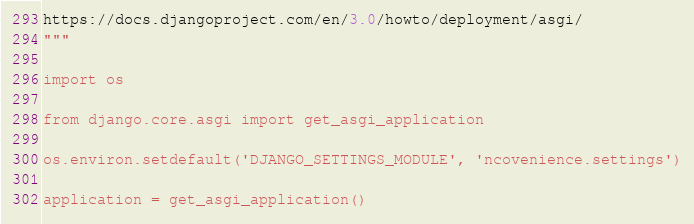<code> <loc_0><loc_0><loc_500><loc_500><_Python_>https://docs.djangoproject.com/en/3.0/howto/deployment/asgi/
"""

import os

from django.core.asgi import get_asgi_application

os.environ.setdefault('DJANGO_SETTINGS_MODULE', 'ncovenience.settings')

application = get_asgi_application()
</code> 